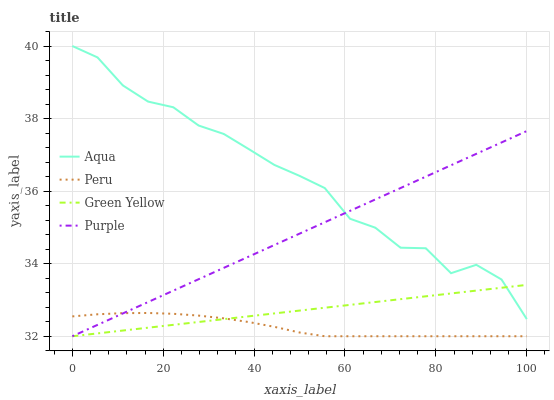Does Peru have the minimum area under the curve?
Answer yes or no. Yes. Does Aqua have the maximum area under the curve?
Answer yes or no. Yes. Does Green Yellow have the minimum area under the curve?
Answer yes or no. No. Does Green Yellow have the maximum area under the curve?
Answer yes or no. No. Is Green Yellow the smoothest?
Answer yes or no. Yes. Is Aqua the roughest?
Answer yes or no. Yes. Is Aqua the smoothest?
Answer yes or no. No. Is Green Yellow the roughest?
Answer yes or no. No. Does Purple have the lowest value?
Answer yes or no. Yes. Does Aqua have the lowest value?
Answer yes or no. No. Does Aqua have the highest value?
Answer yes or no. Yes. Does Green Yellow have the highest value?
Answer yes or no. No. Is Peru less than Aqua?
Answer yes or no. Yes. Is Aqua greater than Peru?
Answer yes or no. Yes. Does Purple intersect Aqua?
Answer yes or no. Yes. Is Purple less than Aqua?
Answer yes or no. No. Is Purple greater than Aqua?
Answer yes or no. No. Does Peru intersect Aqua?
Answer yes or no. No. 